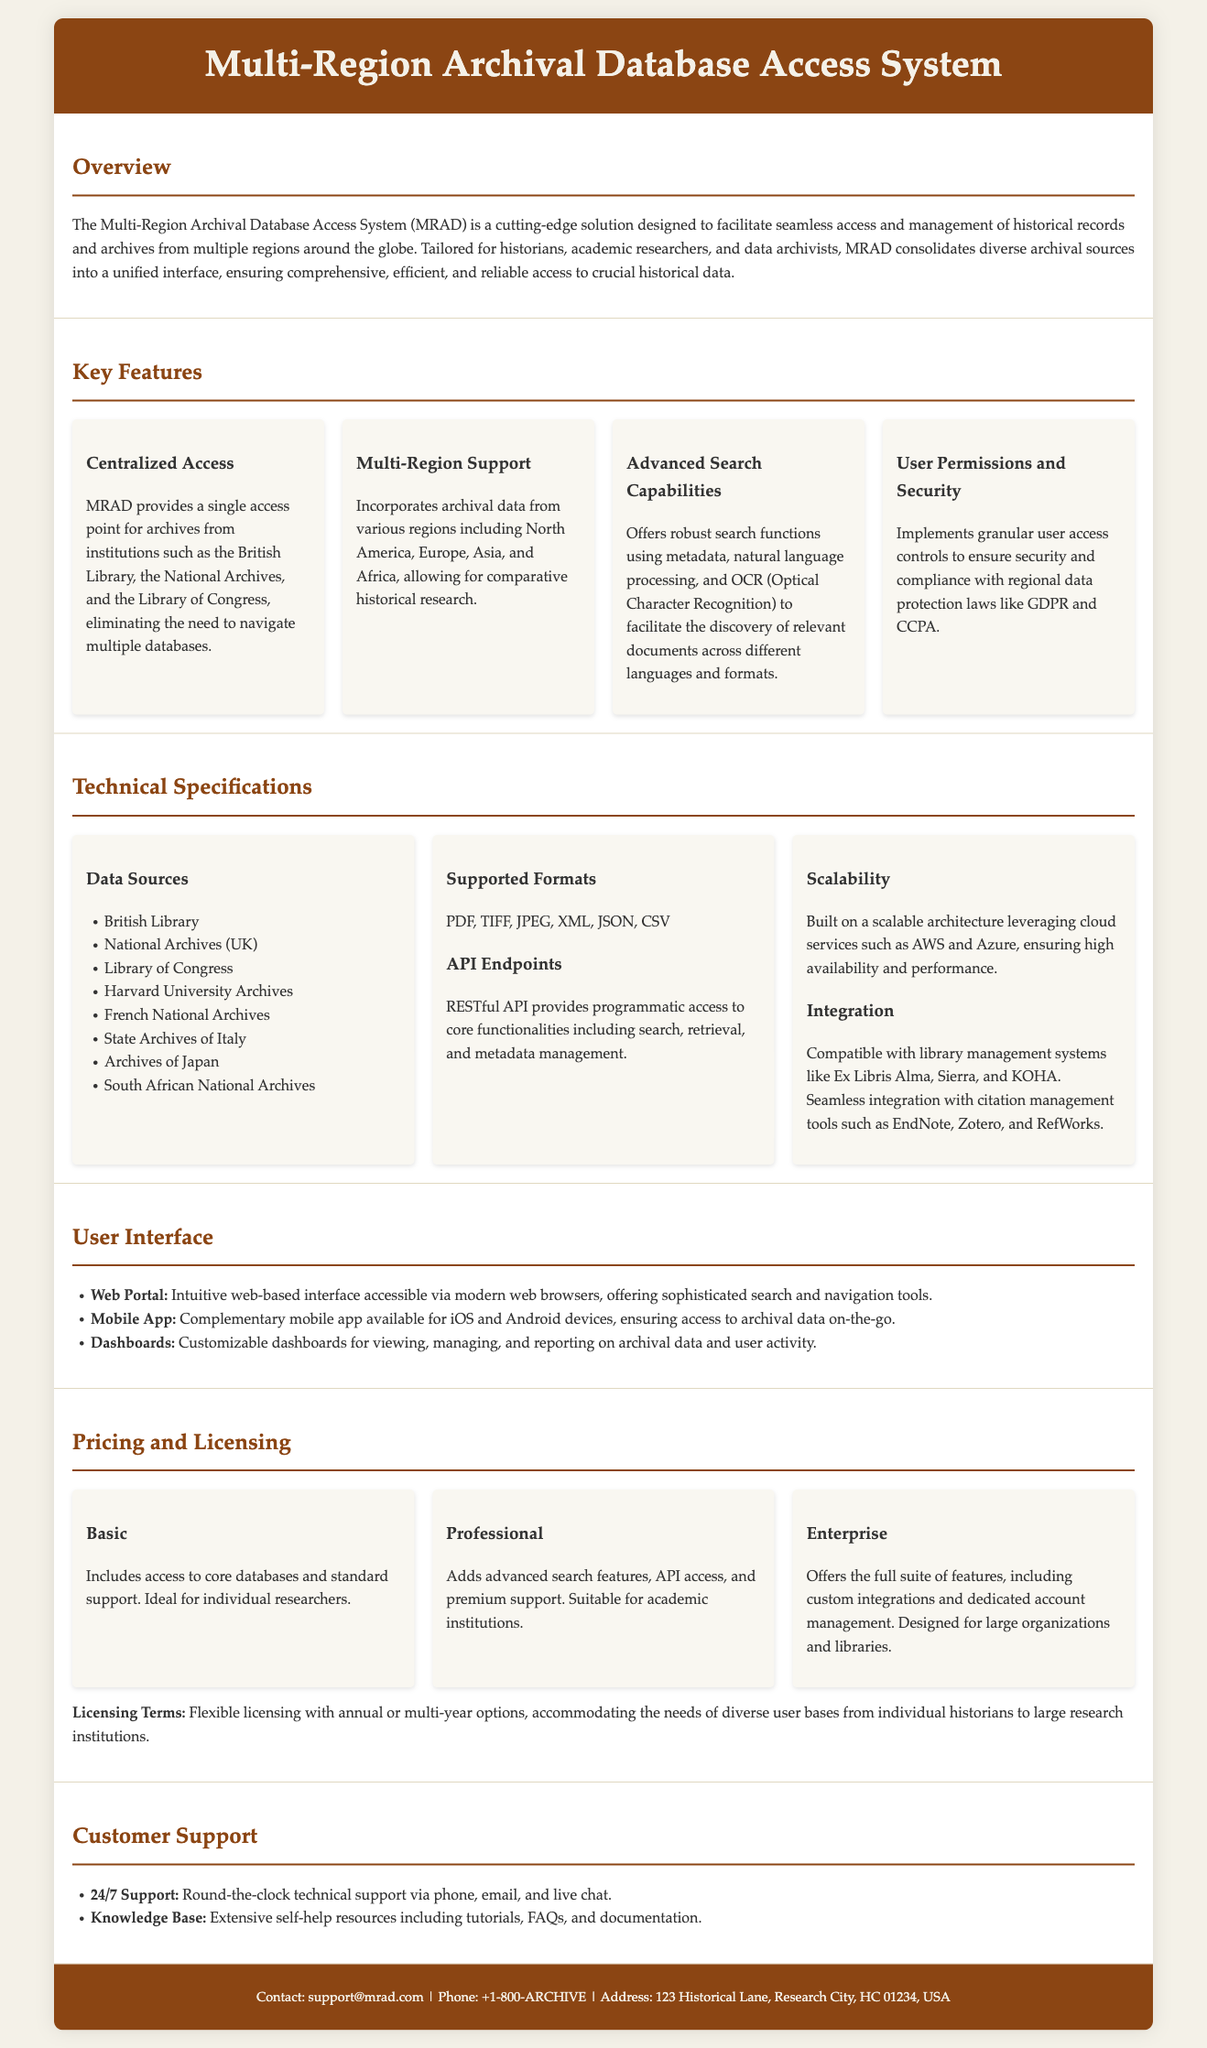What is the name of the system? The name of the system is mentioned in the title of the document.
Answer: Multi-Region Archival Database Access System Who provides centralized access to archives? The document indicates specific institutions that provide archives accessed through the system.
Answer: British Library, National Archives, Library of Congress What is one of the advanced search capabilities mentioned? The document lists specific technologies that enhance search capabilities.
Answer: OCR (Optical Character Recognition) How many pricing plans are available? The document describes different plans offered for the system.
Answer: Three Which region is not listed among the data sources? The question seeks to identify regions not included in the data sources provided in the document.
Answer: Australia What type of user interface is available for mobile devices? The document outlines specific user interfaces associated with the system.
Answer: Mobile App What does the Enterprise plan offer? The document provides details on the features of different pricing plans.
Answer: Custom integrations and dedicated account management What type of support is provided 24/7? The document specifies the type of customer support available around the clock.
Answer: Technical support 